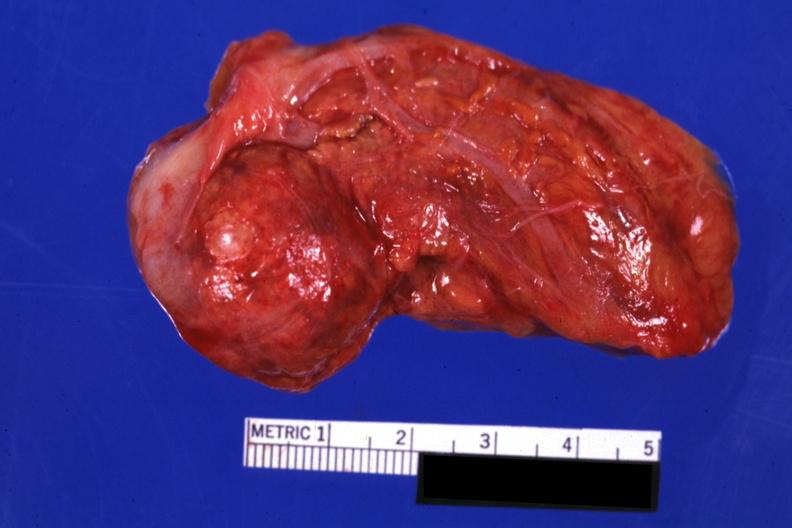where does this belong to?
Answer the question using a single word or phrase. Endocrine system 